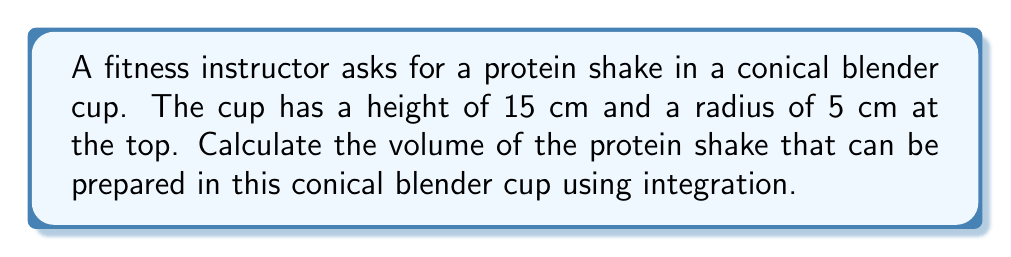Can you solve this math problem? To calculate the volume of the conical blender cup using integration, we'll follow these steps:

1) First, let's visualize the cone:

[asy]
import graph3;
size(200);
currentprojection=perspective(6,3,2);
draw(surface(revolution((0,0)--(5,15),Z)),paleblue);
draw((0,0,0)--(5,0,0)--(5,0,15)--(0,0,15)--cycle,blue);
draw((0,0,0)--(5,0,15),blue);
label("5 cm",(-1,0,7.5),W);
label("15 cm",(5,0,7.5),E);
label("r",(2.5,0,0),S);
label("x",(0,0,7.5),W);
[/asy]

2) The volume of a solid of revolution can be calculated using the formula:

   $$ V = \pi \int_0^h r(x)^2 dx $$

   where $h$ is the height and $r(x)$ is the radius at height $x$.

3) In a cone, the radius at any height $x$ is proportional to the distance from the top. We can express this as:

   $$ r(x) = \frac{5x}{15} = \frac{x}{3} $$

4) Now we can set up our integral:

   $$ V = \pi \int_0^{15} (\frac{x}{3})^2 dx $$

5) Simplify the integrand:

   $$ V = \pi \int_0^{15} \frac{x^2}{9} dx $$

6) Integrate:

   $$ V = \pi [\frac{x^3}{27}]_0^{15} $$

7) Evaluate the integral:

   $$ V = \pi (\frac{15^3}{27} - \frac{0^3}{27}) = \pi \frac{3375}{27} = 125\pi $$

8) Therefore, the volume is $125\pi$ cubic centimeters.
Answer: $125\pi$ cm³ 